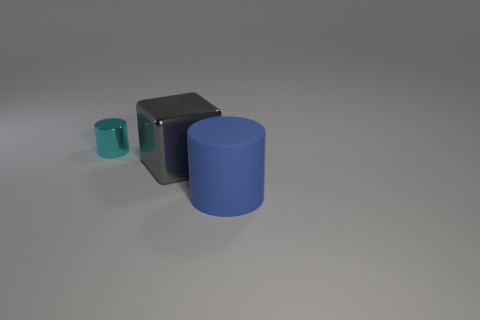Is there an indication of the purpose of these objects? The image doesn't provide explicit context that uncovers the function of these objects, but their simplistic and isolated presentation could imply they're used for illustrative purposes, perhaps as 3D modeling samples or part of a design portfolio, showcasing shapes and colors. How might these objects be utilized in an everyday setting? In a practical setting, these objects might serve as modernistic decor elements, paperweights, or even educational tools to demonstrate geometric solids and color theory to students. 